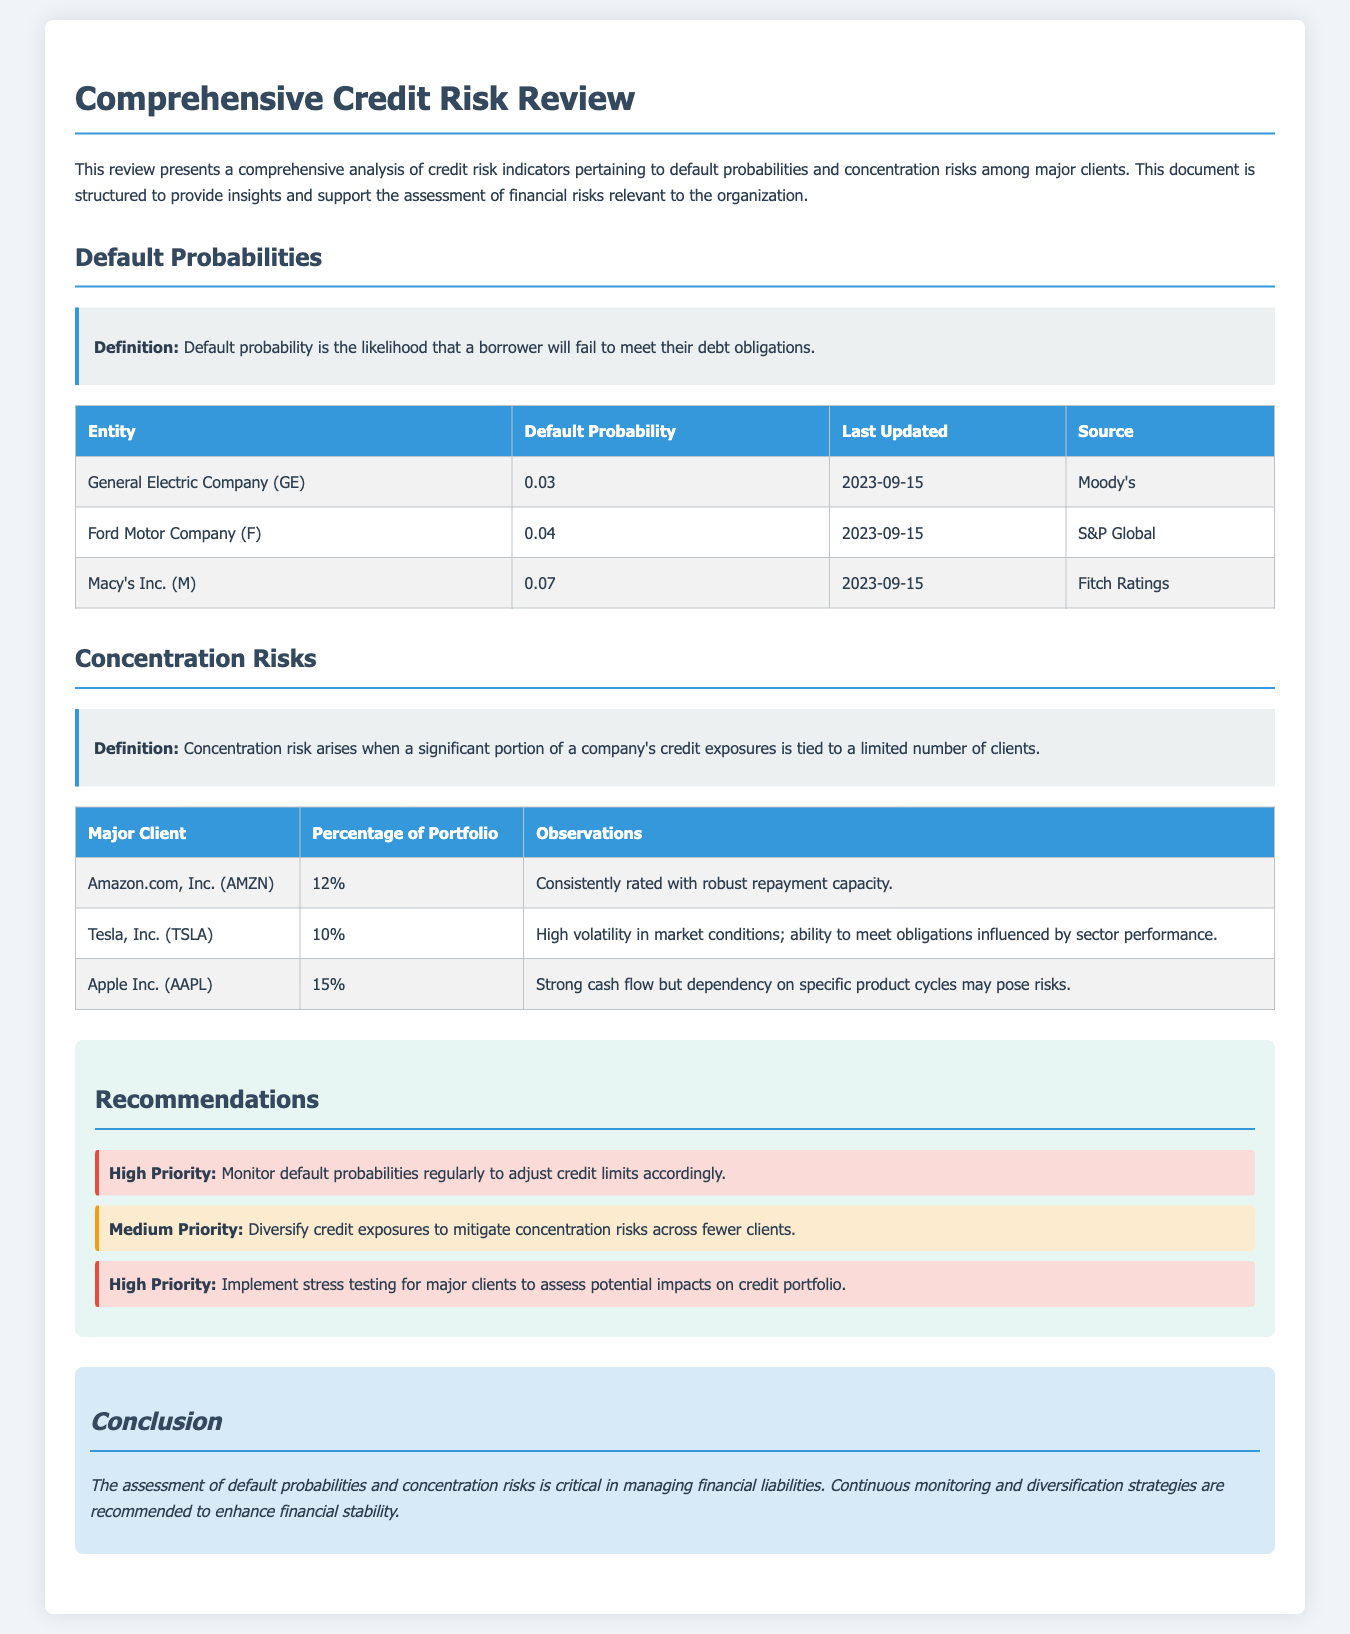What is the default probability for General Electric Company? The default probability for General Electric Company is mentioned in the table of default probabilities.
Answer: 0.03 Who is the source for Ford Motor Company's default probability? The source for Ford Motor Company's default probability is indicated in the respective column in the table.
Answer: S&P Global Which major client has the highest percentage of the portfolio? The major client with the highest percentage of the portfolio is indicated in the concentration risks section.
Answer: Apple Inc. (AAPL) What is the observation for Tesla, Inc.? The observation for Tesla, Inc. is listed in the concentration risks table.
Answer: High volatility in market conditions; ability to meet obligations influenced by sector performance What action is classified as high priority in the recommendations? High priority recommendations are specified in the recommendations section of the document.
Answer: Monitor default probabilities regularly to adjust credit limits accordingly What is the conclusion's focus in the document? The conclusion summarizes the vital points discussed throughout the document, focusing on what aspect is critical for managing financial risks.
Answer: Continuous monitoring and diversification strategies When was the default probability last updated for Macy's Inc.? The last updated date for Macy's Inc. is noted in the default probabilities table.
Answer: 2023-09-15 What percentage of the portfolio is attributed to Amazon.com, Inc.? The percentage of the portfolio for Amazon.com, Inc. is captured in the concentration risks table.
Answer: 12% 